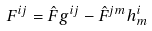Convert formula to latex. <formula><loc_0><loc_0><loc_500><loc_500>F ^ { i j } = \hat { F } g ^ { i j } - \hat { F } ^ { j m } h _ { m } ^ { i }</formula> 